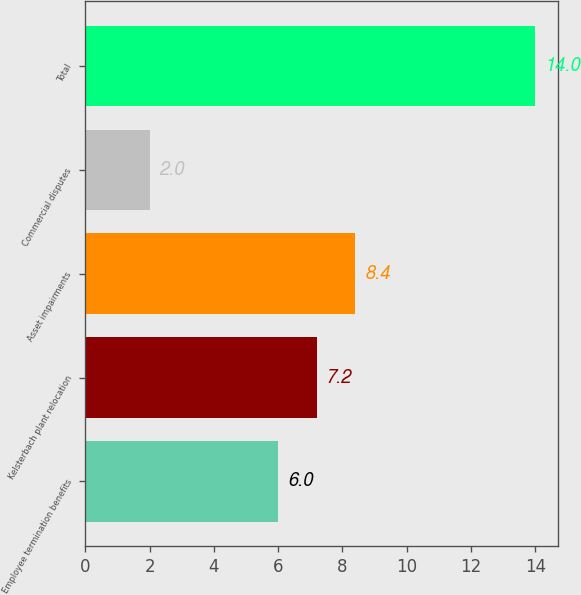<chart> <loc_0><loc_0><loc_500><loc_500><bar_chart><fcel>Employee termination benefits<fcel>Kelsterbach plant relocation<fcel>Asset impairments<fcel>Commercial disputes<fcel>Total<nl><fcel>6<fcel>7.2<fcel>8.4<fcel>2<fcel>14<nl></chart> 